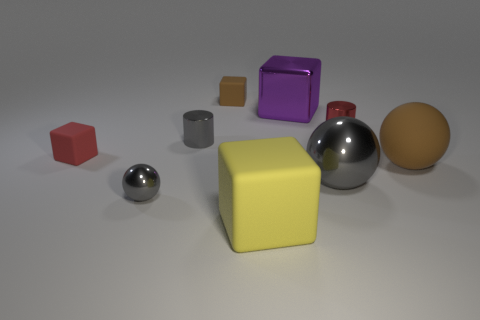The purple object that is the same shape as the big yellow rubber object is what size?
Offer a terse response. Large. How many other large cubes have the same material as the brown block?
Your answer should be very brief. 1. Does the large shiny ball have the same color as the cylinder to the left of the large shiny sphere?
Make the answer very short. Yes. Is the number of large yellow things greater than the number of big metal things?
Give a very brief answer. No. What is the color of the big metallic block?
Your answer should be compact. Purple. There is a shiny ball to the left of the small brown rubber block; is it the same color as the large matte ball?
Give a very brief answer. No. There is another ball that is the same color as the tiny metallic sphere; what material is it?
Make the answer very short. Metal. What number of tiny things have the same color as the big matte ball?
Your response must be concise. 1. There is a big object that is behind the large brown matte thing; is its shape the same as the red matte object?
Your answer should be compact. Yes. Are there fewer yellow rubber blocks that are left of the large matte sphere than matte objects that are behind the yellow matte block?
Offer a terse response. Yes. 